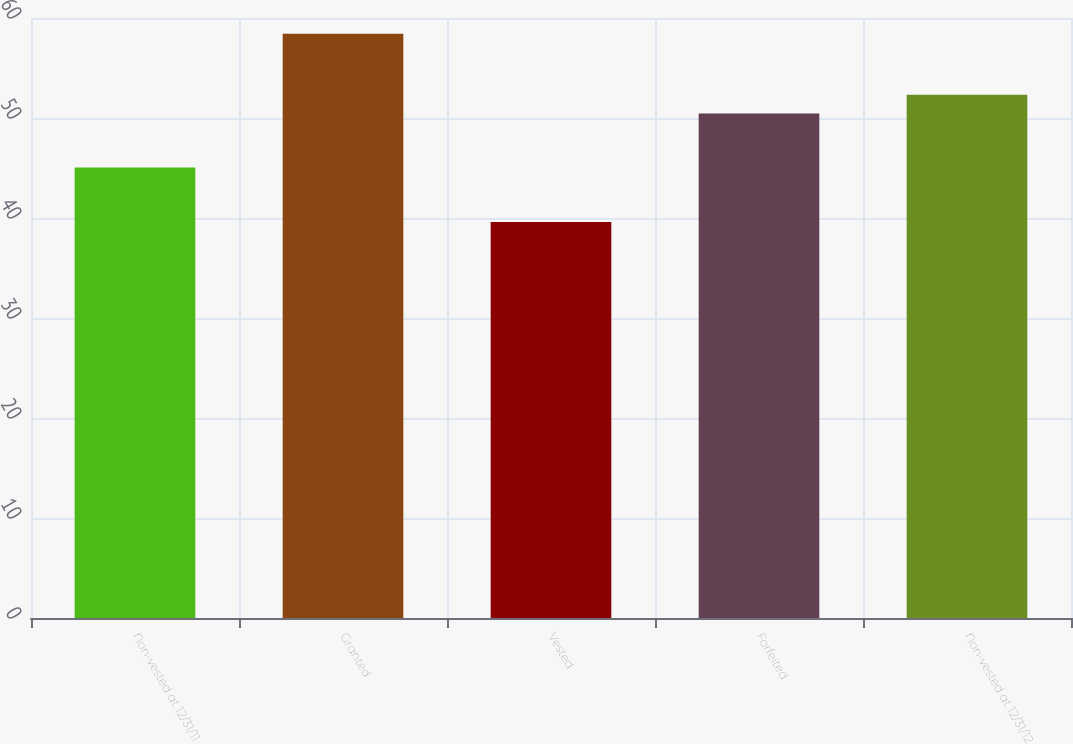Convert chart to OTSL. <chart><loc_0><loc_0><loc_500><loc_500><bar_chart><fcel>Non-vested at 12/31/11<fcel>Granted<fcel>Vested<fcel>Forfeited<fcel>Non-vested at 12/31/12<nl><fcel>45.05<fcel>58.42<fcel>39.61<fcel>50.45<fcel>52.33<nl></chart> 